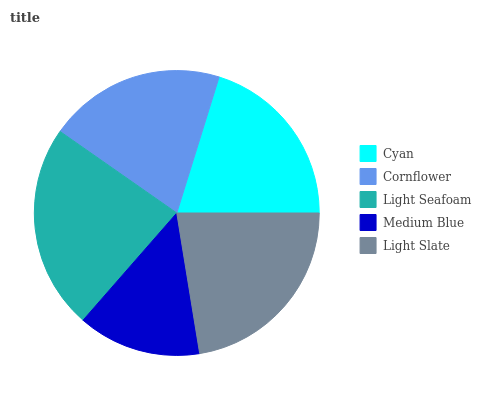Is Medium Blue the minimum?
Answer yes or no. Yes. Is Light Seafoam the maximum?
Answer yes or no. Yes. Is Cornflower the minimum?
Answer yes or no. No. Is Cornflower the maximum?
Answer yes or no. No. Is Cyan greater than Cornflower?
Answer yes or no. Yes. Is Cornflower less than Cyan?
Answer yes or no. Yes. Is Cornflower greater than Cyan?
Answer yes or no. No. Is Cyan less than Cornflower?
Answer yes or no. No. Is Cyan the high median?
Answer yes or no. Yes. Is Cyan the low median?
Answer yes or no. Yes. Is Light Slate the high median?
Answer yes or no. No. Is Cornflower the low median?
Answer yes or no. No. 